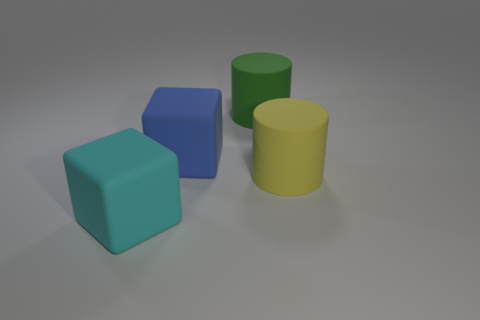Add 4 green objects. How many objects exist? 8 Subtract 0 blue balls. How many objects are left? 4 Subtract all large cyan things. Subtract all blue blocks. How many objects are left? 2 Add 1 large blue rubber cubes. How many large blue rubber cubes are left? 2 Add 3 big blue rubber cubes. How many big blue rubber cubes exist? 4 